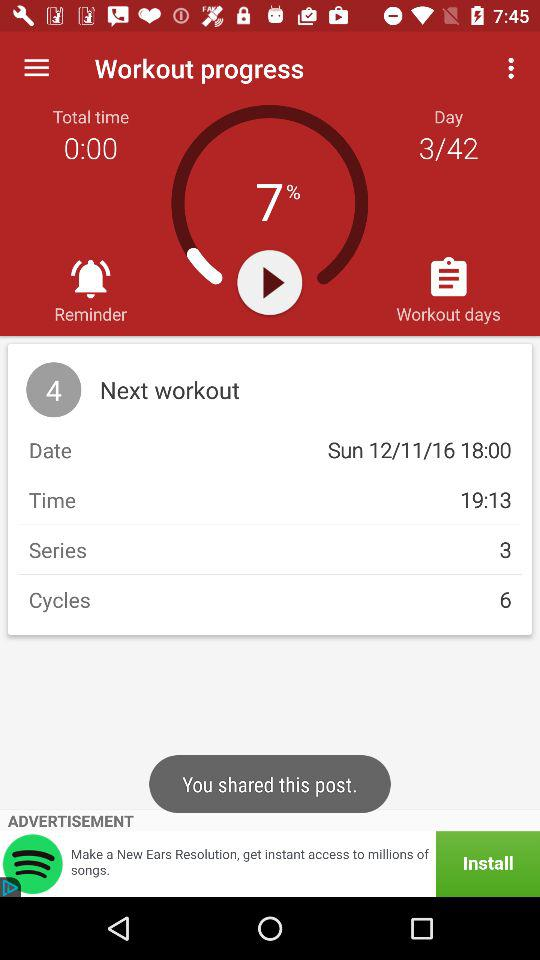What is the date of the next workout? The date of the next workout is Sunday, December 11, 2016. 